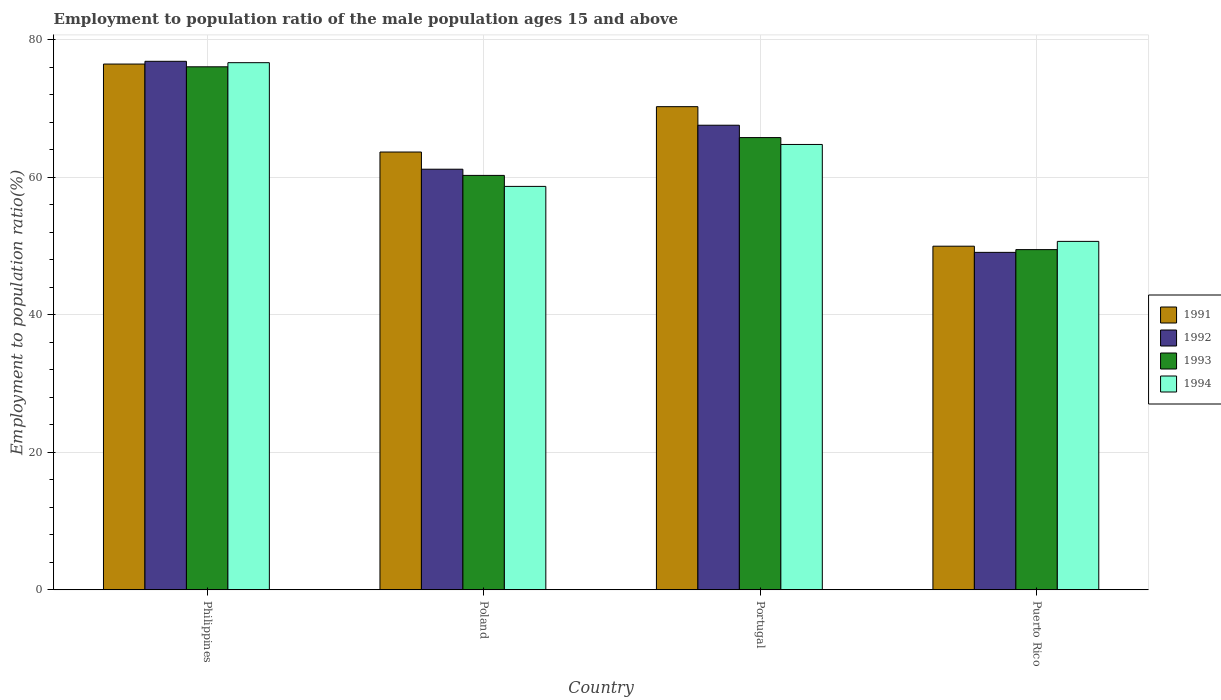How many different coloured bars are there?
Offer a very short reply. 4. How many bars are there on the 2nd tick from the left?
Make the answer very short. 4. How many bars are there on the 4th tick from the right?
Ensure brevity in your answer.  4. What is the label of the 2nd group of bars from the left?
Your answer should be compact. Poland. What is the employment to population ratio in 1994 in Puerto Rico?
Offer a terse response. 50.7. Across all countries, what is the maximum employment to population ratio in 1993?
Your response must be concise. 76.1. Across all countries, what is the minimum employment to population ratio in 1993?
Keep it short and to the point. 49.5. In which country was the employment to population ratio in 1994 maximum?
Your response must be concise. Philippines. In which country was the employment to population ratio in 1994 minimum?
Your answer should be very brief. Puerto Rico. What is the total employment to population ratio in 1991 in the graph?
Your response must be concise. 260.5. What is the difference between the employment to population ratio in 1992 in Portugal and that in Puerto Rico?
Your answer should be compact. 18.5. What is the difference between the employment to population ratio in 1993 in Philippines and the employment to population ratio in 1994 in Poland?
Offer a very short reply. 17.4. What is the average employment to population ratio in 1994 per country?
Ensure brevity in your answer.  62.73. What is the difference between the employment to population ratio of/in 1992 and employment to population ratio of/in 1994 in Philippines?
Your answer should be very brief. 0.2. In how many countries, is the employment to population ratio in 1994 greater than 72 %?
Offer a terse response. 1. What is the ratio of the employment to population ratio in 1994 in Portugal to that in Puerto Rico?
Your answer should be very brief. 1.28. Is the difference between the employment to population ratio in 1992 in Portugal and Puerto Rico greater than the difference between the employment to population ratio in 1994 in Portugal and Puerto Rico?
Your response must be concise. Yes. What is the difference between the highest and the second highest employment to population ratio in 1991?
Make the answer very short. 6.2. What is the difference between the highest and the lowest employment to population ratio in 1992?
Keep it short and to the point. 27.8. Is it the case that in every country, the sum of the employment to population ratio in 1993 and employment to population ratio in 1991 is greater than the sum of employment to population ratio in 1994 and employment to population ratio in 1992?
Keep it short and to the point. No. What does the 3rd bar from the left in Philippines represents?
Give a very brief answer. 1993. What does the 2nd bar from the right in Portugal represents?
Offer a very short reply. 1993. Is it the case that in every country, the sum of the employment to population ratio in 1993 and employment to population ratio in 1992 is greater than the employment to population ratio in 1994?
Your response must be concise. Yes. Are all the bars in the graph horizontal?
Provide a succinct answer. No. How many countries are there in the graph?
Your response must be concise. 4. What is the difference between two consecutive major ticks on the Y-axis?
Your answer should be compact. 20. Does the graph contain grids?
Make the answer very short. Yes. How many legend labels are there?
Offer a terse response. 4. What is the title of the graph?
Make the answer very short. Employment to population ratio of the male population ages 15 and above. What is the label or title of the X-axis?
Offer a terse response. Country. What is the Employment to population ratio(%) of 1991 in Philippines?
Offer a terse response. 76.5. What is the Employment to population ratio(%) in 1992 in Philippines?
Your answer should be compact. 76.9. What is the Employment to population ratio(%) of 1993 in Philippines?
Your answer should be very brief. 76.1. What is the Employment to population ratio(%) in 1994 in Philippines?
Keep it short and to the point. 76.7. What is the Employment to population ratio(%) of 1991 in Poland?
Your answer should be very brief. 63.7. What is the Employment to population ratio(%) in 1992 in Poland?
Provide a short and direct response. 61.2. What is the Employment to population ratio(%) in 1993 in Poland?
Keep it short and to the point. 60.3. What is the Employment to population ratio(%) in 1994 in Poland?
Offer a terse response. 58.7. What is the Employment to population ratio(%) of 1991 in Portugal?
Provide a succinct answer. 70.3. What is the Employment to population ratio(%) in 1992 in Portugal?
Provide a short and direct response. 67.6. What is the Employment to population ratio(%) in 1993 in Portugal?
Offer a terse response. 65.8. What is the Employment to population ratio(%) in 1994 in Portugal?
Provide a succinct answer. 64.8. What is the Employment to population ratio(%) in 1992 in Puerto Rico?
Give a very brief answer. 49.1. What is the Employment to population ratio(%) of 1993 in Puerto Rico?
Your answer should be compact. 49.5. What is the Employment to population ratio(%) in 1994 in Puerto Rico?
Give a very brief answer. 50.7. Across all countries, what is the maximum Employment to population ratio(%) of 1991?
Provide a succinct answer. 76.5. Across all countries, what is the maximum Employment to population ratio(%) in 1992?
Provide a succinct answer. 76.9. Across all countries, what is the maximum Employment to population ratio(%) in 1993?
Provide a succinct answer. 76.1. Across all countries, what is the maximum Employment to population ratio(%) of 1994?
Provide a succinct answer. 76.7. Across all countries, what is the minimum Employment to population ratio(%) in 1991?
Provide a short and direct response. 50. Across all countries, what is the minimum Employment to population ratio(%) in 1992?
Your answer should be very brief. 49.1. Across all countries, what is the minimum Employment to population ratio(%) of 1993?
Your response must be concise. 49.5. Across all countries, what is the minimum Employment to population ratio(%) in 1994?
Provide a succinct answer. 50.7. What is the total Employment to population ratio(%) in 1991 in the graph?
Make the answer very short. 260.5. What is the total Employment to population ratio(%) of 1992 in the graph?
Give a very brief answer. 254.8. What is the total Employment to population ratio(%) in 1993 in the graph?
Your response must be concise. 251.7. What is the total Employment to population ratio(%) in 1994 in the graph?
Make the answer very short. 250.9. What is the difference between the Employment to population ratio(%) of 1994 in Philippines and that in Poland?
Give a very brief answer. 18. What is the difference between the Employment to population ratio(%) in 1992 in Philippines and that in Portugal?
Your answer should be compact. 9.3. What is the difference between the Employment to population ratio(%) in 1993 in Philippines and that in Portugal?
Your response must be concise. 10.3. What is the difference between the Employment to population ratio(%) in 1994 in Philippines and that in Portugal?
Give a very brief answer. 11.9. What is the difference between the Employment to population ratio(%) in 1991 in Philippines and that in Puerto Rico?
Offer a very short reply. 26.5. What is the difference between the Employment to population ratio(%) of 1992 in Philippines and that in Puerto Rico?
Ensure brevity in your answer.  27.8. What is the difference between the Employment to population ratio(%) of 1993 in Philippines and that in Puerto Rico?
Offer a very short reply. 26.6. What is the difference between the Employment to population ratio(%) in 1994 in Philippines and that in Puerto Rico?
Give a very brief answer. 26. What is the difference between the Employment to population ratio(%) of 1992 in Poland and that in Portugal?
Your response must be concise. -6.4. What is the difference between the Employment to population ratio(%) in 1992 in Poland and that in Puerto Rico?
Provide a short and direct response. 12.1. What is the difference between the Employment to population ratio(%) in 1994 in Poland and that in Puerto Rico?
Your response must be concise. 8. What is the difference between the Employment to population ratio(%) in 1991 in Portugal and that in Puerto Rico?
Offer a terse response. 20.3. What is the difference between the Employment to population ratio(%) in 1993 in Portugal and that in Puerto Rico?
Offer a terse response. 16.3. What is the difference between the Employment to population ratio(%) in 1991 in Philippines and the Employment to population ratio(%) in 1993 in Poland?
Offer a very short reply. 16.2. What is the difference between the Employment to population ratio(%) in 1991 in Philippines and the Employment to population ratio(%) in 1994 in Poland?
Make the answer very short. 17.8. What is the difference between the Employment to population ratio(%) of 1992 in Philippines and the Employment to population ratio(%) of 1993 in Poland?
Your answer should be very brief. 16.6. What is the difference between the Employment to population ratio(%) in 1991 in Philippines and the Employment to population ratio(%) in 1992 in Portugal?
Your response must be concise. 8.9. What is the difference between the Employment to population ratio(%) of 1992 in Philippines and the Employment to population ratio(%) of 1993 in Portugal?
Your response must be concise. 11.1. What is the difference between the Employment to population ratio(%) in 1992 in Philippines and the Employment to population ratio(%) in 1994 in Portugal?
Your response must be concise. 12.1. What is the difference between the Employment to population ratio(%) of 1991 in Philippines and the Employment to population ratio(%) of 1992 in Puerto Rico?
Make the answer very short. 27.4. What is the difference between the Employment to population ratio(%) in 1991 in Philippines and the Employment to population ratio(%) in 1993 in Puerto Rico?
Offer a very short reply. 27. What is the difference between the Employment to population ratio(%) of 1991 in Philippines and the Employment to population ratio(%) of 1994 in Puerto Rico?
Make the answer very short. 25.8. What is the difference between the Employment to population ratio(%) of 1992 in Philippines and the Employment to population ratio(%) of 1993 in Puerto Rico?
Give a very brief answer. 27.4. What is the difference between the Employment to population ratio(%) in 1992 in Philippines and the Employment to population ratio(%) in 1994 in Puerto Rico?
Keep it short and to the point. 26.2. What is the difference between the Employment to population ratio(%) of 1993 in Philippines and the Employment to population ratio(%) of 1994 in Puerto Rico?
Your response must be concise. 25.4. What is the difference between the Employment to population ratio(%) in 1991 in Poland and the Employment to population ratio(%) in 1992 in Portugal?
Provide a short and direct response. -3.9. What is the difference between the Employment to population ratio(%) in 1991 in Poland and the Employment to population ratio(%) in 1993 in Portugal?
Provide a succinct answer. -2.1. What is the difference between the Employment to population ratio(%) of 1992 in Poland and the Employment to population ratio(%) of 1994 in Portugal?
Provide a succinct answer. -3.6. What is the difference between the Employment to population ratio(%) in 1993 in Poland and the Employment to population ratio(%) in 1994 in Portugal?
Make the answer very short. -4.5. What is the difference between the Employment to population ratio(%) of 1991 in Poland and the Employment to population ratio(%) of 1993 in Puerto Rico?
Keep it short and to the point. 14.2. What is the difference between the Employment to population ratio(%) of 1992 in Poland and the Employment to population ratio(%) of 1993 in Puerto Rico?
Your response must be concise. 11.7. What is the difference between the Employment to population ratio(%) of 1992 in Poland and the Employment to population ratio(%) of 1994 in Puerto Rico?
Offer a terse response. 10.5. What is the difference between the Employment to population ratio(%) in 1991 in Portugal and the Employment to population ratio(%) in 1992 in Puerto Rico?
Provide a short and direct response. 21.2. What is the difference between the Employment to population ratio(%) of 1991 in Portugal and the Employment to population ratio(%) of 1993 in Puerto Rico?
Keep it short and to the point. 20.8. What is the difference between the Employment to population ratio(%) of 1991 in Portugal and the Employment to population ratio(%) of 1994 in Puerto Rico?
Your answer should be very brief. 19.6. What is the average Employment to population ratio(%) in 1991 per country?
Offer a very short reply. 65.12. What is the average Employment to population ratio(%) of 1992 per country?
Provide a succinct answer. 63.7. What is the average Employment to population ratio(%) in 1993 per country?
Ensure brevity in your answer.  62.92. What is the average Employment to population ratio(%) in 1994 per country?
Provide a short and direct response. 62.73. What is the difference between the Employment to population ratio(%) of 1991 and Employment to population ratio(%) of 1994 in Philippines?
Make the answer very short. -0.2. What is the difference between the Employment to population ratio(%) in 1992 and Employment to population ratio(%) in 1994 in Philippines?
Ensure brevity in your answer.  0.2. What is the difference between the Employment to population ratio(%) in 1993 and Employment to population ratio(%) in 1994 in Philippines?
Offer a terse response. -0.6. What is the difference between the Employment to population ratio(%) of 1991 and Employment to population ratio(%) of 1992 in Poland?
Provide a succinct answer. 2.5. What is the difference between the Employment to population ratio(%) in 1991 and Employment to population ratio(%) in 1993 in Poland?
Make the answer very short. 3.4. What is the difference between the Employment to population ratio(%) of 1991 and Employment to population ratio(%) of 1994 in Poland?
Provide a succinct answer. 5. What is the difference between the Employment to population ratio(%) of 1992 and Employment to population ratio(%) of 1993 in Poland?
Your response must be concise. 0.9. What is the difference between the Employment to population ratio(%) in 1993 and Employment to population ratio(%) in 1994 in Poland?
Make the answer very short. 1.6. What is the difference between the Employment to population ratio(%) in 1991 and Employment to population ratio(%) in 1992 in Portugal?
Ensure brevity in your answer.  2.7. What is the difference between the Employment to population ratio(%) in 1991 and Employment to population ratio(%) in 1993 in Portugal?
Your answer should be compact. 4.5. What is the difference between the Employment to population ratio(%) of 1991 and Employment to population ratio(%) of 1994 in Portugal?
Offer a terse response. 5.5. What is the difference between the Employment to population ratio(%) in 1992 and Employment to population ratio(%) in 1993 in Portugal?
Your answer should be compact. 1.8. What is the difference between the Employment to population ratio(%) in 1992 and Employment to population ratio(%) in 1994 in Portugal?
Your answer should be very brief. 2.8. What is the difference between the Employment to population ratio(%) in 1993 and Employment to population ratio(%) in 1994 in Portugal?
Offer a terse response. 1. What is the difference between the Employment to population ratio(%) of 1991 and Employment to population ratio(%) of 1994 in Puerto Rico?
Provide a succinct answer. -0.7. What is the difference between the Employment to population ratio(%) of 1992 and Employment to population ratio(%) of 1993 in Puerto Rico?
Make the answer very short. -0.4. What is the difference between the Employment to population ratio(%) in 1993 and Employment to population ratio(%) in 1994 in Puerto Rico?
Keep it short and to the point. -1.2. What is the ratio of the Employment to population ratio(%) in 1991 in Philippines to that in Poland?
Provide a succinct answer. 1.2. What is the ratio of the Employment to population ratio(%) in 1992 in Philippines to that in Poland?
Your answer should be very brief. 1.26. What is the ratio of the Employment to population ratio(%) of 1993 in Philippines to that in Poland?
Your response must be concise. 1.26. What is the ratio of the Employment to population ratio(%) of 1994 in Philippines to that in Poland?
Give a very brief answer. 1.31. What is the ratio of the Employment to population ratio(%) of 1991 in Philippines to that in Portugal?
Offer a terse response. 1.09. What is the ratio of the Employment to population ratio(%) in 1992 in Philippines to that in Portugal?
Provide a succinct answer. 1.14. What is the ratio of the Employment to population ratio(%) in 1993 in Philippines to that in Portugal?
Ensure brevity in your answer.  1.16. What is the ratio of the Employment to population ratio(%) in 1994 in Philippines to that in Portugal?
Keep it short and to the point. 1.18. What is the ratio of the Employment to population ratio(%) in 1991 in Philippines to that in Puerto Rico?
Offer a terse response. 1.53. What is the ratio of the Employment to population ratio(%) in 1992 in Philippines to that in Puerto Rico?
Your answer should be very brief. 1.57. What is the ratio of the Employment to population ratio(%) in 1993 in Philippines to that in Puerto Rico?
Your answer should be very brief. 1.54. What is the ratio of the Employment to population ratio(%) in 1994 in Philippines to that in Puerto Rico?
Keep it short and to the point. 1.51. What is the ratio of the Employment to population ratio(%) of 1991 in Poland to that in Portugal?
Provide a short and direct response. 0.91. What is the ratio of the Employment to population ratio(%) in 1992 in Poland to that in Portugal?
Give a very brief answer. 0.91. What is the ratio of the Employment to population ratio(%) of 1993 in Poland to that in Portugal?
Ensure brevity in your answer.  0.92. What is the ratio of the Employment to population ratio(%) in 1994 in Poland to that in Portugal?
Make the answer very short. 0.91. What is the ratio of the Employment to population ratio(%) of 1991 in Poland to that in Puerto Rico?
Provide a short and direct response. 1.27. What is the ratio of the Employment to population ratio(%) in 1992 in Poland to that in Puerto Rico?
Make the answer very short. 1.25. What is the ratio of the Employment to population ratio(%) in 1993 in Poland to that in Puerto Rico?
Your response must be concise. 1.22. What is the ratio of the Employment to population ratio(%) in 1994 in Poland to that in Puerto Rico?
Make the answer very short. 1.16. What is the ratio of the Employment to population ratio(%) of 1991 in Portugal to that in Puerto Rico?
Provide a succinct answer. 1.41. What is the ratio of the Employment to population ratio(%) of 1992 in Portugal to that in Puerto Rico?
Keep it short and to the point. 1.38. What is the ratio of the Employment to population ratio(%) of 1993 in Portugal to that in Puerto Rico?
Make the answer very short. 1.33. What is the ratio of the Employment to population ratio(%) of 1994 in Portugal to that in Puerto Rico?
Offer a terse response. 1.28. What is the difference between the highest and the second highest Employment to population ratio(%) of 1992?
Give a very brief answer. 9.3. What is the difference between the highest and the second highest Employment to population ratio(%) in 1993?
Give a very brief answer. 10.3. What is the difference between the highest and the lowest Employment to population ratio(%) in 1992?
Your answer should be compact. 27.8. What is the difference between the highest and the lowest Employment to population ratio(%) of 1993?
Give a very brief answer. 26.6. 